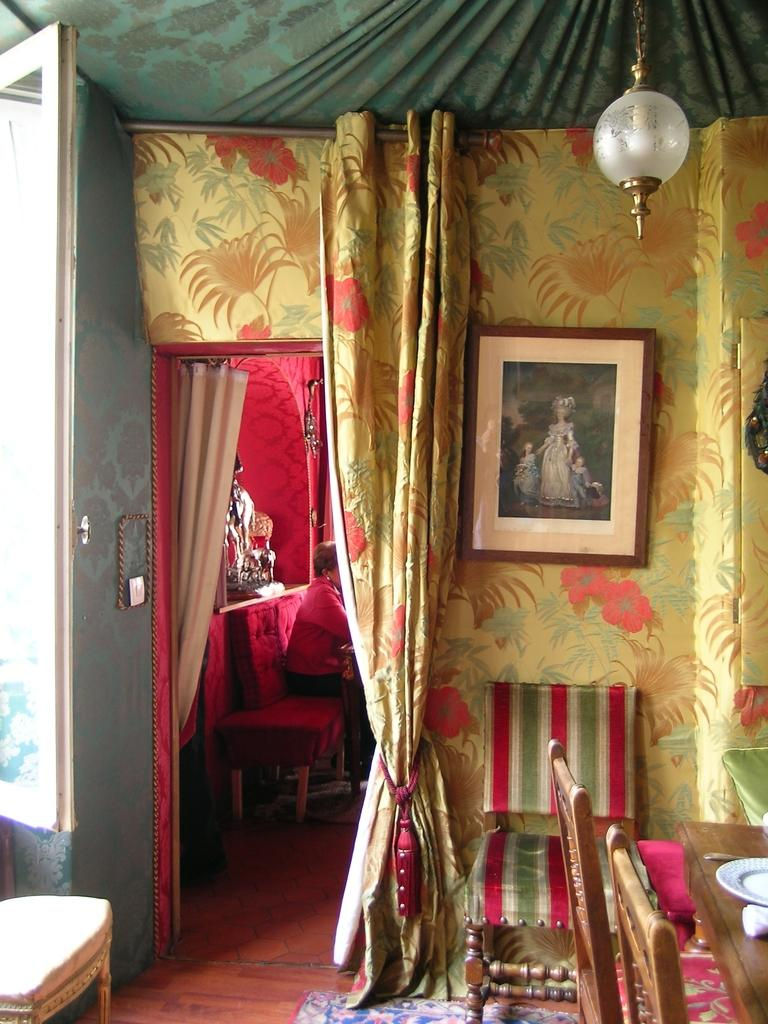What is the person in the image doing? The person is sitting on a sofa in the image. What type of furniture is present in the image besides the sofa? There are chairs in the image. What is on the table in the image? There is a plate on the table. What can be seen hanging on the wall in the image? There is a frame on the wall. What type of window treatment is present in the image? There is a curtain in the image. What type of hand can be seen holding a water pitcher in the image? There is no hand or water pitcher present in the image. 